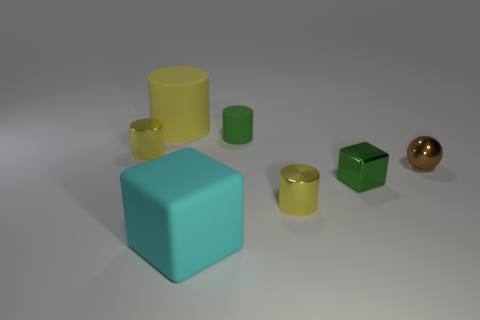Is there a rubber object that is behind the shiny cylinder behind the yellow cylinder that is right of the cyan matte object?
Your answer should be very brief. Yes. What shape is the yellow matte object that is the same size as the cyan cube?
Provide a short and direct response. Cylinder. There is a matte cylinder on the left side of the big cyan rubber cube; does it have the same size as the green object that is behind the small brown ball?
Keep it short and to the point. No. How many large green metal cylinders are there?
Your response must be concise. 0. There is a block in front of the block behind the large matte object that is in front of the sphere; how big is it?
Your answer should be very brief. Large. Does the large cube have the same color as the small rubber cylinder?
Keep it short and to the point. No. Is there any other thing that is the same size as the sphere?
Your answer should be compact. Yes. There is a green rubber object; what number of small green cubes are in front of it?
Keep it short and to the point. 1. Is the number of green things that are on the right side of the tiny green metal cube the same as the number of big balls?
Your answer should be very brief. Yes. How many things are brown cylinders or small brown objects?
Your answer should be compact. 1. 